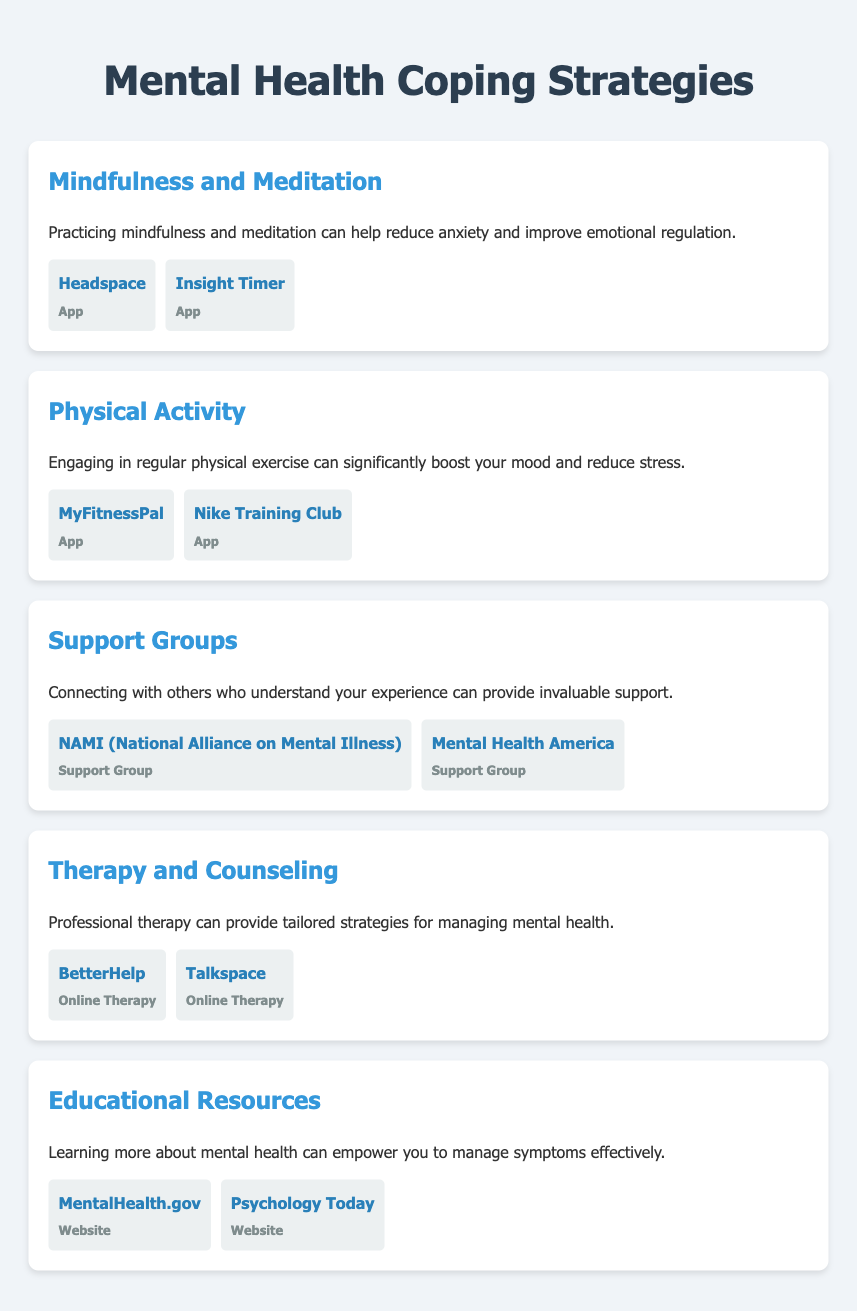what is the first coping strategy listed? The first coping strategy mentioned in the document is "Mindfulness and Meditation."
Answer: Mindfulness and Meditation how many resources are provided for support groups? The document lists two resources under the support groups strategy.
Answer: 2 what is the purpose of professional therapy according to the document? The document states that professional therapy provides tailored strategies for managing mental health.
Answer: Tailored strategies which app is mentioned for mindfulness practice? The document mentions "Headspace" as an app for mindfulness.
Answer: Headspace what type of resources does MentalHealth.gov provide? MentalHealth.gov is classified as a website in the resources provided.
Answer: Website which app focuses on physical activity? "MyFitnessPal" is an app that focuses on physical activity.
Answer: MyFitnessPal how many strategies are detailed in the document? There are five coping strategies outlined in the document.
Answer: 5 what is the theme of the educational resources section? The theme focuses on empowering individuals to manage symptoms effectively through learning.
Answer: Empowerment through learning which company offers online therapy according to the document? "BetterHelp" is mentioned as an option for online therapy.
Answer: BetterHelp 